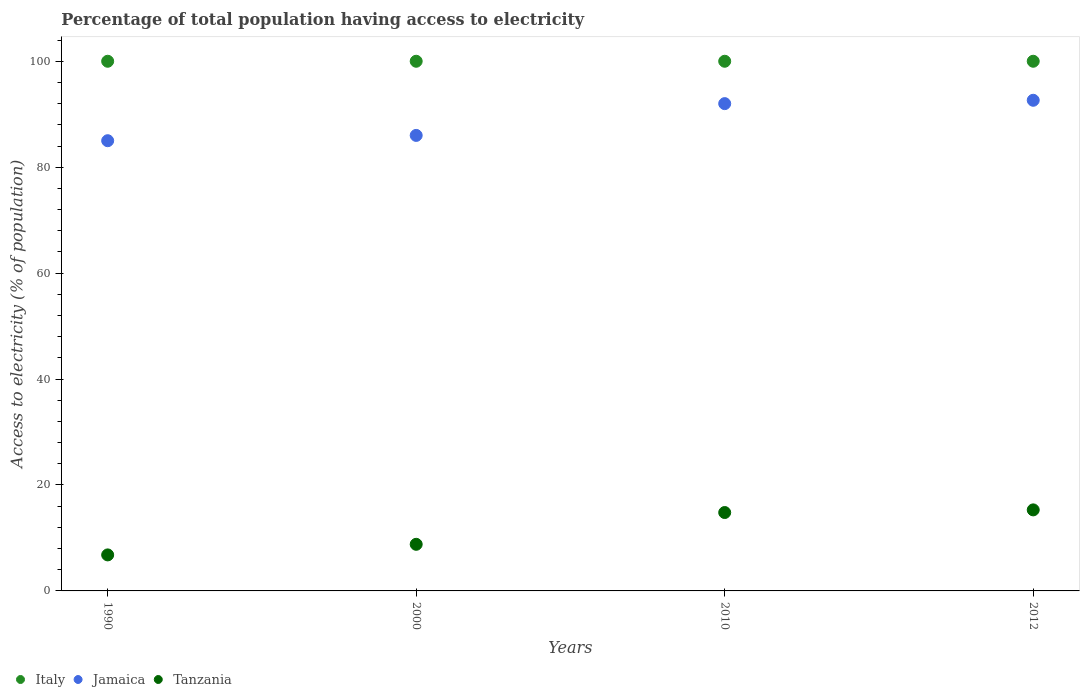Is the number of dotlines equal to the number of legend labels?
Make the answer very short. Yes. Across all years, what is the maximum percentage of population that have access to electricity in Italy?
Provide a short and direct response. 100. Across all years, what is the minimum percentage of population that have access to electricity in Tanzania?
Offer a very short reply. 6.8. What is the total percentage of population that have access to electricity in Jamaica in the graph?
Offer a terse response. 355.63. What is the difference between the percentage of population that have access to electricity in Tanzania in 2012 and the percentage of population that have access to electricity in Jamaica in 2010?
Keep it short and to the point. -76.7. What is the average percentage of population that have access to electricity in Italy per year?
Your answer should be compact. 100. In the year 2000, what is the difference between the percentage of population that have access to electricity in Tanzania and percentage of population that have access to electricity in Italy?
Provide a short and direct response. -91.2. In how many years, is the percentage of population that have access to electricity in Jamaica greater than 8 %?
Offer a terse response. 4. What is the ratio of the percentage of population that have access to electricity in Italy in 2010 to that in 2012?
Make the answer very short. 1. Is the percentage of population that have access to electricity in Italy in 2000 less than that in 2010?
Offer a very short reply. No. What is the difference between the highest and the second highest percentage of population that have access to electricity in Jamaica?
Keep it short and to the point. 0.63. Is the sum of the percentage of population that have access to electricity in Jamaica in 2010 and 2012 greater than the maximum percentage of population that have access to electricity in Tanzania across all years?
Offer a very short reply. Yes. Is it the case that in every year, the sum of the percentage of population that have access to electricity in Italy and percentage of population that have access to electricity in Jamaica  is greater than the percentage of population that have access to electricity in Tanzania?
Make the answer very short. Yes. Does the percentage of population that have access to electricity in Italy monotonically increase over the years?
Your answer should be compact. No. Is the percentage of population that have access to electricity in Tanzania strictly greater than the percentage of population that have access to electricity in Jamaica over the years?
Your answer should be compact. No. How many dotlines are there?
Make the answer very short. 3. Does the graph contain grids?
Offer a very short reply. No. How many legend labels are there?
Keep it short and to the point. 3. How are the legend labels stacked?
Your answer should be compact. Horizontal. What is the title of the graph?
Ensure brevity in your answer.  Percentage of total population having access to electricity. Does "Congo (Republic)" appear as one of the legend labels in the graph?
Ensure brevity in your answer.  No. What is the label or title of the X-axis?
Provide a short and direct response. Years. What is the label or title of the Y-axis?
Your answer should be compact. Access to electricity (% of population). What is the Access to electricity (% of population) of Jamaica in 1990?
Your answer should be compact. 85. What is the Access to electricity (% of population) of Tanzania in 1990?
Ensure brevity in your answer.  6.8. What is the Access to electricity (% of population) of Jamaica in 2010?
Give a very brief answer. 92. What is the Access to electricity (% of population) in Tanzania in 2010?
Provide a short and direct response. 14.8. What is the Access to electricity (% of population) in Italy in 2012?
Provide a succinct answer. 100. What is the Access to electricity (% of population) of Jamaica in 2012?
Make the answer very short. 92.63. What is the Access to electricity (% of population) in Tanzania in 2012?
Offer a terse response. 15.3. Across all years, what is the maximum Access to electricity (% of population) in Italy?
Offer a very short reply. 100. Across all years, what is the maximum Access to electricity (% of population) of Jamaica?
Your answer should be compact. 92.63. Across all years, what is the maximum Access to electricity (% of population) in Tanzania?
Offer a very short reply. 15.3. Across all years, what is the minimum Access to electricity (% of population) in Italy?
Your answer should be very brief. 100. Across all years, what is the minimum Access to electricity (% of population) of Jamaica?
Provide a short and direct response. 85. Across all years, what is the minimum Access to electricity (% of population) in Tanzania?
Ensure brevity in your answer.  6.8. What is the total Access to electricity (% of population) in Jamaica in the graph?
Provide a succinct answer. 355.63. What is the total Access to electricity (% of population) in Tanzania in the graph?
Ensure brevity in your answer.  45.7. What is the difference between the Access to electricity (% of population) of Italy in 1990 and that in 2000?
Offer a terse response. 0. What is the difference between the Access to electricity (% of population) of Italy in 1990 and that in 2010?
Provide a succinct answer. 0. What is the difference between the Access to electricity (% of population) in Italy in 1990 and that in 2012?
Give a very brief answer. 0. What is the difference between the Access to electricity (% of population) of Jamaica in 1990 and that in 2012?
Offer a very short reply. -7.63. What is the difference between the Access to electricity (% of population) in Tanzania in 1990 and that in 2012?
Provide a succinct answer. -8.5. What is the difference between the Access to electricity (% of population) in Italy in 2000 and that in 2010?
Keep it short and to the point. 0. What is the difference between the Access to electricity (% of population) of Jamaica in 2000 and that in 2010?
Offer a terse response. -6. What is the difference between the Access to electricity (% of population) in Jamaica in 2000 and that in 2012?
Ensure brevity in your answer.  -6.63. What is the difference between the Access to electricity (% of population) of Tanzania in 2000 and that in 2012?
Offer a very short reply. -6.5. What is the difference between the Access to electricity (% of population) in Jamaica in 2010 and that in 2012?
Offer a terse response. -0.63. What is the difference between the Access to electricity (% of population) of Tanzania in 2010 and that in 2012?
Provide a succinct answer. -0.5. What is the difference between the Access to electricity (% of population) in Italy in 1990 and the Access to electricity (% of population) in Jamaica in 2000?
Your answer should be compact. 14. What is the difference between the Access to electricity (% of population) of Italy in 1990 and the Access to electricity (% of population) of Tanzania in 2000?
Your response must be concise. 91.2. What is the difference between the Access to electricity (% of population) in Jamaica in 1990 and the Access to electricity (% of population) in Tanzania in 2000?
Make the answer very short. 76.2. What is the difference between the Access to electricity (% of population) of Italy in 1990 and the Access to electricity (% of population) of Tanzania in 2010?
Your answer should be compact. 85.2. What is the difference between the Access to electricity (% of population) in Jamaica in 1990 and the Access to electricity (% of population) in Tanzania in 2010?
Provide a short and direct response. 70.2. What is the difference between the Access to electricity (% of population) of Italy in 1990 and the Access to electricity (% of population) of Jamaica in 2012?
Make the answer very short. 7.37. What is the difference between the Access to electricity (% of population) of Italy in 1990 and the Access to electricity (% of population) of Tanzania in 2012?
Provide a succinct answer. 84.7. What is the difference between the Access to electricity (% of population) of Jamaica in 1990 and the Access to electricity (% of population) of Tanzania in 2012?
Make the answer very short. 69.7. What is the difference between the Access to electricity (% of population) of Italy in 2000 and the Access to electricity (% of population) of Jamaica in 2010?
Your response must be concise. 8. What is the difference between the Access to electricity (% of population) of Italy in 2000 and the Access to electricity (% of population) of Tanzania in 2010?
Make the answer very short. 85.2. What is the difference between the Access to electricity (% of population) in Jamaica in 2000 and the Access to electricity (% of population) in Tanzania in 2010?
Your response must be concise. 71.2. What is the difference between the Access to electricity (% of population) in Italy in 2000 and the Access to electricity (% of population) in Jamaica in 2012?
Your response must be concise. 7.37. What is the difference between the Access to electricity (% of population) in Italy in 2000 and the Access to electricity (% of population) in Tanzania in 2012?
Offer a terse response. 84.7. What is the difference between the Access to electricity (% of population) in Jamaica in 2000 and the Access to electricity (% of population) in Tanzania in 2012?
Provide a short and direct response. 70.7. What is the difference between the Access to electricity (% of population) in Italy in 2010 and the Access to electricity (% of population) in Jamaica in 2012?
Your answer should be compact. 7.37. What is the difference between the Access to electricity (% of population) of Italy in 2010 and the Access to electricity (% of population) of Tanzania in 2012?
Your answer should be compact. 84.7. What is the difference between the Access to electricity (% of population) of Jamaica in 2010 and the Access to electricity (% of population) of Tanzania in 2012?
Provide a succinct answer. 76.7. What is the average Access to electricity (% of population) in Jamaica per year?
Offer a terse response. 88.91. What is the average Access to electricity (% of population) of Tanzania per year?
Provide a succinct answer. 11.43. In the year 1990, what is the difference between the Access to electricity (% of population) in Italy and Access to electricity (% of population) in Jamaica?
Provide a short and direct response. 15. In the year 1990, what is the difference between the Access to electricity (% of population) in Italy and Access to electricity (% of population) in Tanzania?
Offer a very short reply. 93.2. In the year 1990, what is the difference between the Access to electricity (% of population) in Jamaica and Access to electricity (% of population) in Tanzania?
Give a very brief answer. 78.2. In the year 2000, what is the difference between the Access to electricity (% of population) in Italy and Access to electricity (% of population) in Tanzania?
Keep it short and to the point. 91.2. In the year 2000, what is the difference between the Access to electricity (% of population) of Jamaica and Access to electricity (% of population) of Tanzania?
Your response must be concise. 77.2. In the year 2010, what is the difference between the Access to electricity (% of population) of Italy and Access to electricity (% of population) of Jamaica?
Keep it short and to the point. 8. In the year 2010, what is the difference between the Access to electricity (% of population) in Italy and Access to electricity (% of population) in Tanzania?
Make the answer very short. 85.2. In the year 2010, what is the difference between the Access to electricity (% of population) in Jamaica and Access to electricity (% of population) in Tanzania?
Your response must be concise. 77.2. In the year 2012, what is the difference between the Access to electricity (% of population) of Italy and Access to electricity (% of population) of Jamaica?
Offer a terse response. 7.37. In the year 2012, what is the difference between the Access to electricity (% of population) of Italy and Access to electricity (% of population) of Tanzania?
Provide a short and direct response. 84.7. In the year 2012, what is the difference between the Access to electricity (% of population) of Jamaica and Access to electricity (% of population) of Tanzania?
Your answer should be very brief. 77.33. What is the ratio of the Access to electricity (% of population) in Italy in 1990 to that in 2000?
Make the answer very short. 1. What is the ratio of the Access to electricity (% of population) of Jamaica in 1990 to that in 2000?
Ensure brevity in your answer.  0.99. What is the ratio of the Access to electricity (% of population) of Tanzania in 1990 to that in 2000?
Your answer should be very brief. 0.77. What is the ratio of the Access to electricity (% of population) of Italy in 1990 to that in 2010?
Offer a very short reply. 1. What is the ratio of the Access to electricity (% of population) of Jamaica in 1990 to that in 2010?
Your response must be concise. 0.92. What is the ratio of the Access to electricity (% of population) in Tanzania in 1990 to that in 2010?
Ensure brevity in your answer.  0.46. What is the ratio of the Access to electricity (% of population) of Jamaica in 1990 to that in 2012?
Your response must be concise. 0.92. What is the ratio of the Access to electricity (% of population) of Tanzania in 1990 to that in 2012?
Offer a very short reply. 0.44. What is the ratio of the Access to electricity (% of population) of Italy in 2000 to that in 2010?
Ensure brevity in your answer.  1. What is the ratio of the Access to electricity (% of population) of Jamaica in 2000 to that in 2010?
Your answer should be compact. 0.93. What is the ratio of the Access to electricity (% of population) of Tanzania in 2000 to that in 2010?
Make the answer very short. 0.59. What is the ratio of the Access to electricity (% of population) of Italy in 2000 to that in 2012?
Your answer should be compact. 1. What is the ratio of the Access to electricity (% of population) of Jamaica in 2000 to that in 2012?
Give a very brief answer. 0.93. What is the ratio of the Access to electricity (% of population) of Tanzania in 2000 to that in 2012?
Offer a terse response. 0.58. What is the ratio of the Access to electricity (% of population) of Italy in 2010 to that in 2012?
Make the answer very short. 1. What is the ratio of the Access to electricity (% of population) of Jamaica in 2010 to that in 2012?
Your answer should be compact. 0.99. What is the ratio of the Access to electricity (% of population) in Tanzania in 2010 to that in 2012?
Provide a succinct answer. 0.97. What is the difference between the highest and the second highest Access to electricity (% of population) in Jamaica?
Your answer should be compact. 0.63. What is the difference between the highest and the second highest Access to electricity (% of population) of Tanzania?
Your answer should be very brief. 0.5. What is the difference between the highest and the lowest Access to electricity (% of population) of Jamaica?
Make the answer very short. 7.63. 